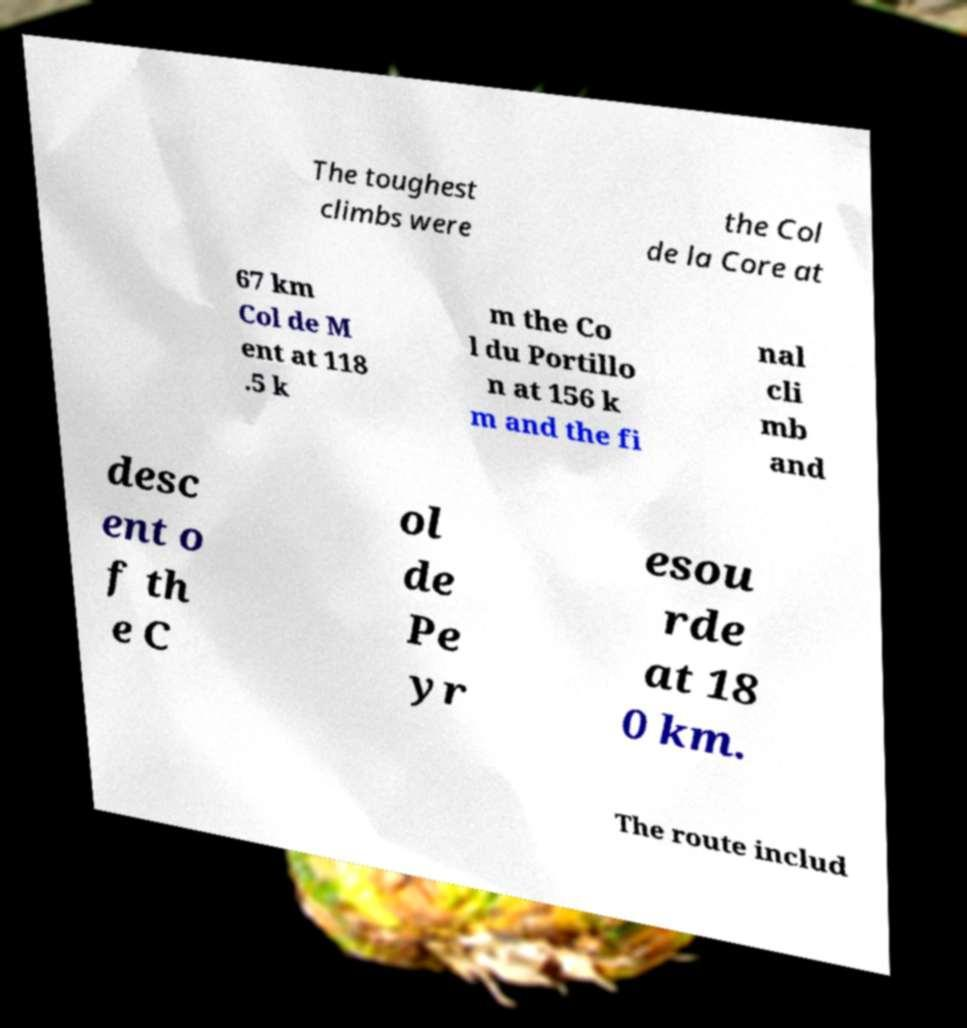Please read and relay the text visible in this image. What does it say? The toughest climbs were the Col de la Core at 67 km Col de M ent at 118 .5 k m the Co l du Portillo n at 156 k m and the fi nal cli mb and desc ent o f th e C ol de Pe yr esou rde at 18 0 km. The route includ 